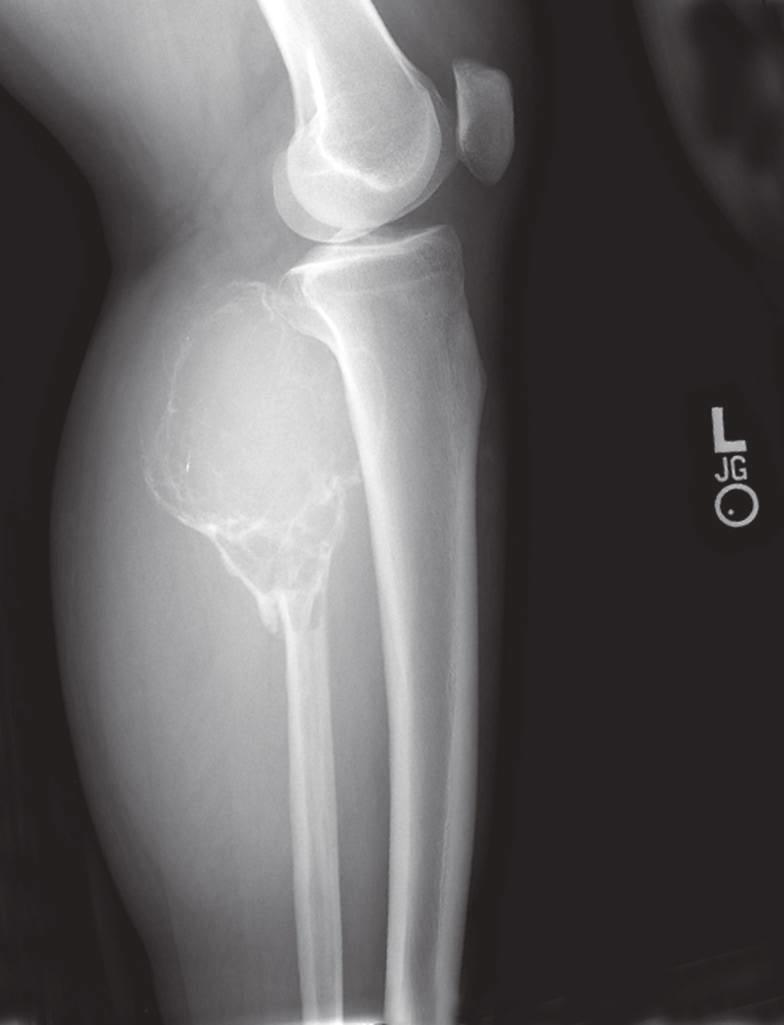what is predominantly lytic, expansile with destruction of the cortex?
Answer the question using a single word or phrase. Giant cell tumor of the proximal fibula 